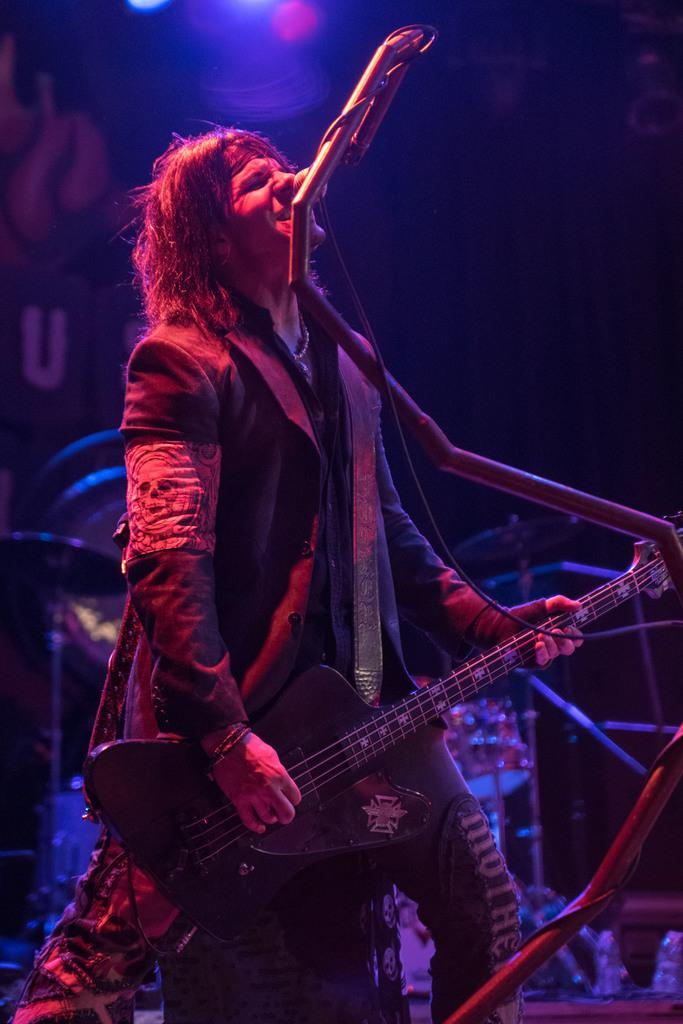What is the person in the image doing? The person in the image is singing. What instrument is the person holding? The person is holding a guitar. What device is in front of the person? There is a microphone in front of the person. What other musical instruments can be seen in the image? There are other musical instruments visible in the image. What type of island can be seen in the background of the image? There is no island visible in the image; it is focused on the person singing and the musical instruments. What kind of apparel is the person wearing in the image? The provided facts do not mention the person's clothing, so we cannot determine the type of apparel they are wearing. 